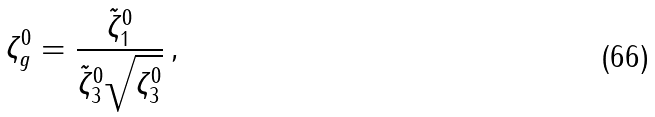Convert formula to latex. <formula><loc_0><loc_0><loc_500><loc_500>\zeta ^ { 0 } _ { g } = \frac { \tilde { \zeta } ^ { 0 } _ { 1 } } { \tilde { \zeta } ^ { 0 } _ { 3 } \sqrt { \zeta _ { 3 } ^ { 0 } } } \, ,</formula> 